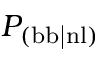<formula> <loc_0><loc_0><loc_500><loc_500>P _ { ( b b | n l ) }</formula> 